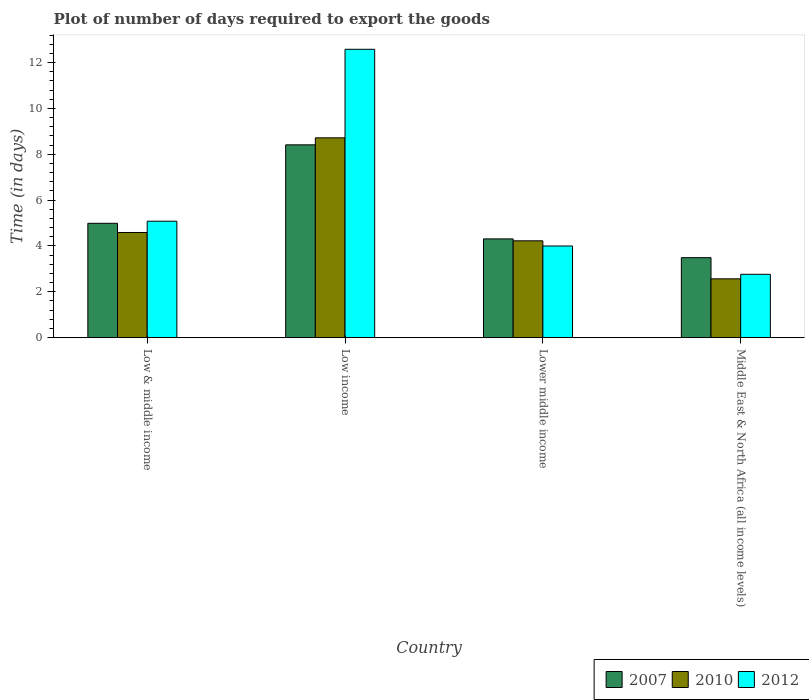In how many cases, is the number of bars for a given country not equal to the number of legend labels?
Provide a short and direct response. 0. What is the time required to export goods in 2007 in Low & middle income?
Offer a very short reply. 4.99. Across all countries, what is the maximum time required to export goods in 2012?
Keep it short and to the point. 12.58. Across all countries, what is the minimum time required to export goods in 2010?
Make the answer very short. 2.57. In which country was the time required to export goods in 2010 minimum?
Offer a terse response. Middle East & North Africa (all income levels). What is the total time required to export goods in 2010 in the graph?
Your answer should be very brief. 20.1. What is the difference between the time required to export goods in 2012 in Low income and that in Lower middle income?
Ensure brevity in your answer.  8.58. What is the difference between the time required to export goods in 2012 in Middle East & North Africa (all income levels) and the time required to export goods in 2007 in Low income?
Keep it short and to the point. -5.65. What is the average time required to export goods in 2010 per country?
Give a very brief answer. 5.03. What is the difference between the time required to export goods of/in 2012 and time required to export goods of/in 2010 in Low income?
Your response must be concise. 3.86. What is the ratio of the time required to export goods in 2010 in Low & middle income to that in Middle East & North Africa (all income levels)?
Provide a succinct answer. 1.79. Is the time required to export goods in 2012 in Low income less than that in Lower middle income?
Offer a terse response. No. Is the difference between the time required to export goods in 2012 in Low income and Lower middle income greater than the difference between the time required to export goods in 2010 in Low income and Lower middle income?
Your answer should be very brief. Yes. What is the difference between the highest and the second highest time required to export goods in 2010?
Offer a very short reply. 4.13. What is the difference between the highest and the lowest time required to export goods in 2012?
Give a very brief answer. 9.82. In how many countries, is the time required to export goods in 2007 greater than the average time required to export goods in 2007 taken over all countries?
Give a very brief answer. 1. What does the 1st bar from the right in Low income represents?
Ensure brevity in your answer.  2012. Is it the case that in every country, the sum of the time required to export goods in 2012 and time required to export goods in 2010 is greater than the time required to export goods in 2007?
Your answer should be compact. Yes. How many countries are there in the graph?
Keep it short and to the point. 4. Does the graph contain any zero values?
Your answer should be compact. No. Does the graph contain grids?
Offer a terse response. No. How many legend labels are there?
Give a very brief answer. 3. How are the legend labels stacked?
Give a very brief answer. Horizontal. What is the title of the graph?
Offer a terse response. Plot of number of days required to export the goods. Does "1961" appear as one of the legend labels in the graph?
Ensure brevity in your answer.  No. What is the label or title of the Y-axis?
Make the answer very short. Time (in days). What is the Time (in days) in 2007 in Low & middle income?
Your answer should be compact. 4.99. What is the Time (in days) of 2010 in Low & middle income?
Your response must be concise. 4.59. What is the Time (in days) of 2012 in Low & middle income?
Your answer should be very brief. 5.08. What is the Time (in days) in 2007 in Low income?
Your response must be concise. 8.41. What is the Time (in days) of 2010 in Low income?
Offer a very short reply. 8.72. What is the Time (in days) of 2012 in Low income?
Make the answer very short. 12.58. What is the Time (in days) in 2007 in Lower middle income?
Make the answer very short. 4.31. What is the Time (in days) in 2010 in Lower middle income?
Your response must be concise. 4.23. What is the Time (in days) of 2007 in Middle East & North Africa (all income levels)?
Offer a very short reply. 3.49. What is the Time (in days) in 2010 in Middle East & North Africa (all income levels)?
Provide a succinct answer. 2.57. What is the Time (in days) in 2012 in Middle East & North Africa (all income levels)?
Provide a short and direct response. 2.76. Across all countries, what is the maximum Time (in days) in 2007?
Your answer should be very brief. 8.41. Across all countries, what is the maximum Time (in days) in 2010?
Make the answer very short. 8.72. Across all countries, what is the maximum Time (in days) in 2012?
Provide a short and direct response. 12.58. Across all countries, what is the minimum Time (in days) in 2007?
Your response must be concise. 3.49. Across all countries, what is the minimum Time (in days) of 2010?
Your response must be concise. 2.57. Across all countries, what is the minimum Time (in days) of 2012?
Provide a succinct answer. 2.76. What is the total Time (in days) in 2007 in the graph?
Offer a terse response. 21.2. What is the total Time (in days) in 2010 in the graph?
Offer a very short reply. 20.1. What is the total Time (in days) of 2012 in the graph?
Your answer should be very brief. 24.43. What is the difference between the Time (in days) of 2007 in Low & middle income and that in Low income?
Keep it short and to the point. -3.42. What is the difference between the Time (in days) in 2010 in Low & middle income and that in Low income?
Your response must be concise. -4.13. What is the difference between the Time (in days) in 2012 in Low & middle income and that in Low income?
Offer a very short reply. -7.5. What is the difference between the Time (in days) of 2007 in Low & middle income and that in Lower middle income?
Give a very brief answer. 0.68. What is the difference between the Time (in days) of 2010 in Low & middle income and that in Lower middle income?
Provide a short and direct response. 0.36. What is the difference between the Time (in days) in 2012 in Low & middle income and that in Lower middle income?
Your response must be concise. 1.08. What is the difference between the Time (in days) in 2007 in Low & middle income and that in Middle East & North Africa (all income levels)?
Keep it short and to the point. 1.5. What is the difference between the Time (in days) in 2010 in Low & middle income and that in Middle East & North Africa (all income levels)?
Keep it short and to the point. 2.02. What is the difference between the Time (in days) of 2012 in Low & middle income and that in Middle East & North Africa (all income levels)?
Ensure brevity in your answer.  2.32. What is the difference between the Time (in days) of 2007 in Low income and that in Lower middle income?
Make the answer very short. 4.1. What is the difference between the Time (in days) of 2010 in Low income and that in Lower middle income?
Your answer should be compact. 4.49. What is the difference between the Time (in days) of 2012 in Low income and that in Lower middle income?
Your answer should be very brief. 8.58. What is the difference between the Time (in days) of 2007 in Low income and that in Middle East & North Africa (all income levels)?
Make the answer very short. 4.92. What is the difference between the Time (in days) in 2010 in Low income and that in Middle East & North Africa (all income levels)?
Your answer should be very brief. 6.15. What is the difference between the Time (in days) of 2012 in Low income and that in Middle East & North Africa (all income levels)?
Make the answer very short. 9.82. What is the difference between the Time (in days) of 2007 in Lower middle income and that in Middle East & North Africa (all income levels)?
Your answer should be compact. 0.82. What is the difference between the Time (in days) in 2010 in Lower middle income and that in Middle East & North Africa (all income levels)?
Keep it short and to the point. 1.66. What is the difference between the Time (in days) in 2012 in Lower middle income and that in Middle East & North Africa (all income levels)?
Make the answer very short. 1.24. What is the difference between the Time (in days) in 2007 in Low & middle income and the Time (in days) in 2010 in Low income?
Provide a succinct answer. -3.73. What is the difference between the Time (in days) of 2007 in Low & middle income and the Time (in days) of 2012 in Low income?
Provide a short and direct response. -7.59. What is the difference between the Time (in days) in 2010 in Low & middle income and the Time (in days) in 2012 in Low income?
Ensure brevity in your answer.  -7.99. What is the difference between the Time (in days) of 2007 in Low & middle income and the Time (in days) of 2010 in Lower middle income?
Make the answer very short. 0.76. What is the difference between the Time (in days) in 2010 in Low & middle income and the Time (in days) in 2012 in Lower middle income?
Offer a very short reply. 0.59. What is the difference between the Time (in days) of 2007 in Low & middle income and the Time (in days) of 2010 in Middle East & North Africa (all income levels)?
Give a very brief answer. 2.42. What is the difference between the Time (in days) in 2007 in Low & middle income and the Time (in days) in 2012 in Middle East & North Africa (all income levels)?
Offer a very short reply. 2.23. What is the difference between the Time (in days) of 2010 in Low & middle income and the Time (in days) of 2012 in Middle East & North Africa (all income levels)?
Your answer should be very brief. 1.82. What is the difference between the Time (in days) of 2007 in Low income and the Time (in days) of 2010 in Lower middle income?
Make the answer very short. 4.19. What is the difference between the Time (in days) in 2007 in Low income and the Time (in days) in 2012 in Lower middle income?
Your answer should be very brief. 4.41. What is the difference between the Time (in days) of 2010 in Low income and the Time (in days) of 2012 in Lower middle income?
Offer a terse response. 4.72. What is the difference between the Time (in days) of 2007 in Low income and the Time (in days) of 2010 in Middle East & North Africa (all income levels)?
Your response must be concise. 5.85. What is the difference between the Time (in days) of 2007 in Low income and the Time (in days) of 2012 in Middle East & North Africa (all income levels)?
Your answer should be compact. 5.65. What is the difference between the Time (in days) of 2010 in Low income and the Time (in days) of 2012 in Middle East & North Africa (all income levels)?
Provide a succinct answer. 5.96. What is the difference between the Time (in days) of 2007 in Lower middle income and the Time (in days) of 2010 in Middle East & North Africa (all income levels)?
Offer a terse response. 1.74. What is the difference between the Time (in days) of 2007 in Lower middle income and the Time (in days) of 2012 in Middle East & North Africa (all income levels)?
Offer a very short reply. 1.55. What is the difference between the Time (in days) in 2010 in Lower middle income and the Time (in days) in 2012 in Middle East & North Africa (all income levels)?
Your answer should be very brief. 1.46. What is the average Time (in days) in 2007 per country?
Your answer should be very brief. 5.3. What is the average Time (in days) in 2010 per country?
Your answer should be very brief. 5.03. What is the average Time (in days) of 2012 per country?
Your answer should be very brief. 6.11. What is the difference between the Time (in days) of 2007 and Time (in days) of 2010 in Low & middle income?
Keep it short and to the point. 0.4. What is the difference between the Time (in days) in 2007 and Time (in days) in 2012 in Low & middle income?
Offer a terse response. -0.09. What is the difference between the Time (in days) in 2010 and Time (in days) in 2012 in Low & middle income?
Your answer should be very brief. -0.49. What is the difference between the Time (in days) in 2007 and Time (in days) in 2010 in Low income?
Your answer should be very brief. -0.31. What is the difference between the Time (in days) of 2007 and Time (in days) of 2012 in Low income?
Your answer should be compact. -4.17. What is the difference between the Time (in days) of 2010 and Time (in days) of 2012 in Low income?
Ensure brevity in your answer.  -3.86. What is the difference between the Time (in days) in 2007 and Time (in days) in 2010 in Lower middle income?
Your answer should be very brief. 0.08. What is the difference between the Time (in days) in 2007 and Time (in days) in 2012 in Lower middle income?
Your response must be concise. 0.31. What is the difference between the Time (in days) of 2010 and Time (in days) of 2012 in Lower middle income?
Your response must be concise. 0.23. What is the difference between the Time (in days) of 2007 and Time (in days) of 2010 in Middle East & North Africa (all income levels)?
Your answer should be very brief. 0.92. What is the difference between the Time (in days) of 2007 and Time (in days) of 2012 in Middle East & North Africa (all income levels)?
Offer a terse response. 0.73. What is the difference between the Time (in days) in 2010 and Time (in days) in 2012 in Middle East & North Africa (all income levels)?
Make the answer very short. -0.2. What is the ratio of the Time (in days) of 2007 in Low & middle income to that in Low income?
Your response must be concise. 0.59. What is the ratio of the Time (in days) of 2010 in Low & middle income to that in Low income?
Provide a short and direct response. 0.53. What is the ratio of the Time (in days) in 2012 in Low & middle income to that in Low income?
Offer a terse response. 0.4. What is the ratio of the Time (in days) of 2007 in Low & middle income to that in Lower middle income?
Offer a terse response. 1.16. What is the ratio of the Time (in days) of 2010 in Low & middle income to that in Lower middle income?
Your answer should be compact. 1.09. What is the ratio of the Time (in days) of 2012 in Low & middle income to that in Lower middle income?
Offer a very short reply. 1.27. What is the ratio of the Time (in days) in 2007 in Low & middle income to that in Middle East & North Africa (all income levels)?
Make the answer very short. 1.43. What is the ratio of the Time (in days) in 2010 in Low & middle income to that in Middle East & North Africa (all income levels)?
Your answer should be compact. 1.79. What is the ratio of the Time (in days) of 2012 in Low & middle income to that in Middle East & North Africa (all income levels)?
Your answer should be compact. 1.84. What is the ratio of the Time (in days) of 2007 in Low income to that in Lower middle income?
Make the answer very short. 1.95. What is the ratio of the Time (in days) in 2010 in Low income to that in Lower middle income?
Keep it short and to the point. 2.06. What is the ratio of the Time (in days) in 2012 in Low income to that in Lower middle income?
Ensure brevity in your answer.  3.15. What is the ratio of the Time (in days) in 2007 in Low income to that in Middle East & North Africa (all income levels)?
Keep it short and to the point. 2.41. What is the ratio of the Time (in days) in 2010 in Low income to that in Middle East & North Africa (all income levels)?
Give a very brief answer. 3.4. What is the ratio of the Time (in days) of 2012 in Low income to that in Middle East & North Africa (all income levels)?
Your response must be concise. 4.55. What is the ratio of the Time (in days) of 2007 in Lower middle income to that in Middle East & North Africa (all income levels)?
Keep it short and to the point. 1.24. What is the ratio of the Time (in days) of 2010 in Lower middle income to that in Middle East & North Africa (all income levels)?
Keep it short and to the point. 1.65. What is the ratio of the Time (in days) in 2012 in Lower middle income to that in Middle East & North Africa (all income levels)?
Your response must be concise. 1.45. What is the difference between the highest and the second highest Time (in days) of 2007?
Provide a succinct answer. 3.42. What is the difference between the highest and the second highest Time (in days) in 2010?
Offer a terse response. 4.13. What is the difference between the highest and the second highest Time (in days) of 2012?
Provide a succinct answer. 7.5. What is the difference between the highest and the lowest Time (in days) of 2007?
Keep it short and to the point. 4.92. What is the difference between the highest and the lowest Time (in days) of 2010?
Make the answer very short. 6.15. What is the difference between the highest and the lowest Time (in days) of 2012?
Provide a short and direct response. 9.82. 